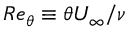Convert formula to latex. <formula><loc_0><loc_0><loc_500><loc_500>R e _ { \theta } \equiv \theta U _ { \infty } / \nu</formula> 